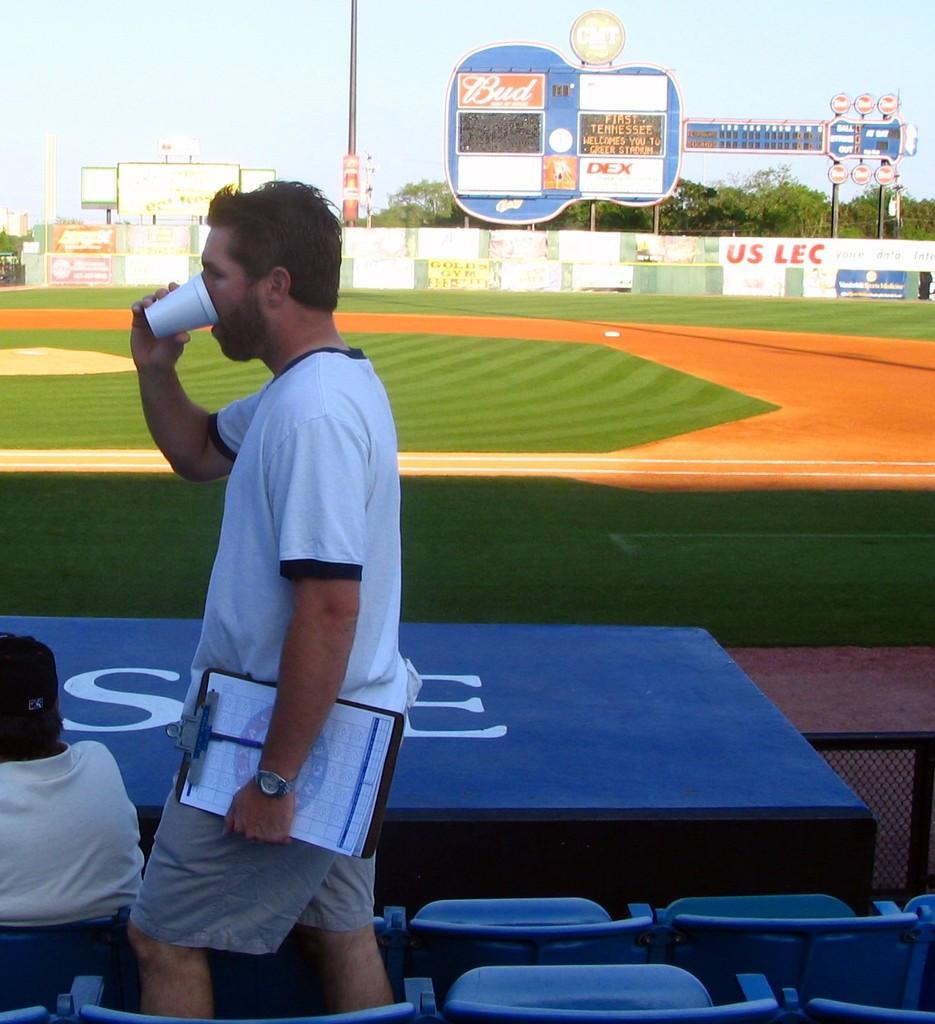<image>
Provide a brief description of the given image. A screen board reads "First Tennessee Welcomes You to Greer Stadium" 